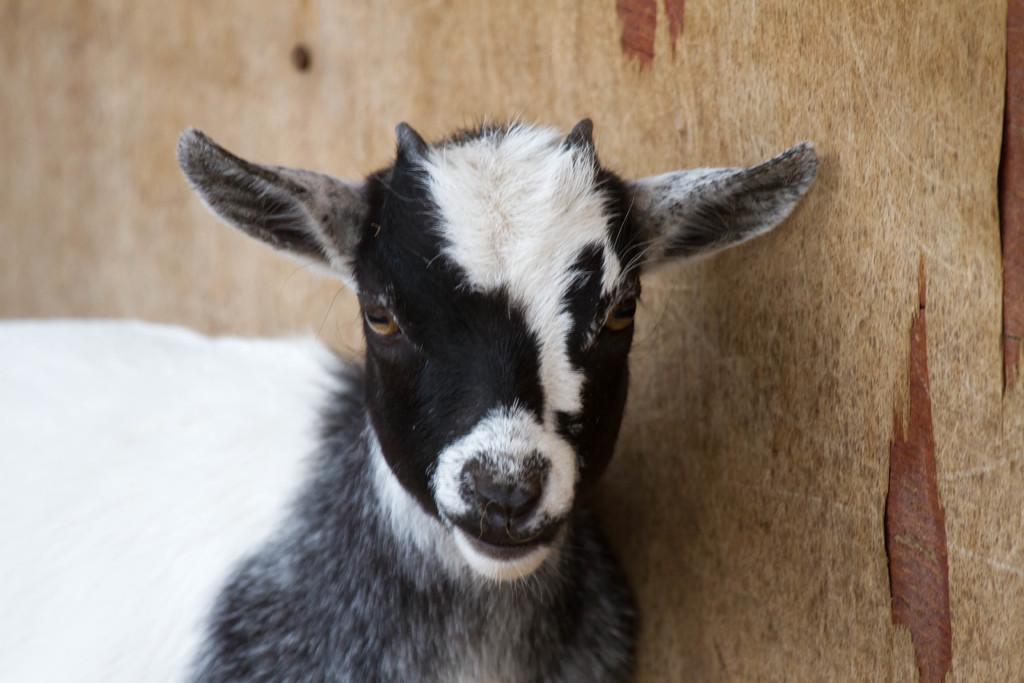In one or two sentences, can you explain what this image depicts? In this picture there is a goat in the center of the image. 